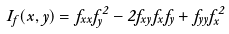<formula> <loc_0><loc_0><loc_500><loc_500>I _ { f } ( x , y ) = f _ { x x } f _ { y } ^ { 2 } - 2 f _ { x y } f _ { x } f _ { y } + f _ { y y } f _ { x } ^ { 2 }</formula> 